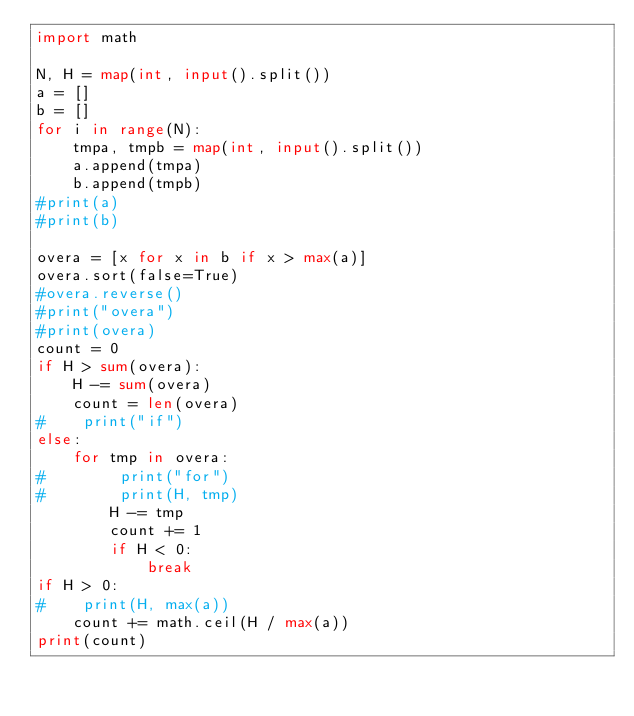<code> <loc_0><loc_0><loc_500><loc_500><_Python_>import math

N, H = map(int, input().split())
a = []
b = []
for i in range(N):
    tmpa, tmpb = map(int, input().split())
    a.append(tmpa)
    b.append(tmpb)
#print(a)
#print(b)

overa = [x for x in b if x > max(a)]
overa.sort(false=True)
#overa.reverse()
#print("overa")
#print(overa)
count = 0
if H > sum(overa):
    H -= sum(overa)
    count = len(overa)
#    print("if")
else:
    for tmp in overa:
#        print("for")
#        print(H, tmp)
        H -= tmp
        count += 1
        if H < 0:
            break
if H > 0:
#    print(H, max(a))
    count += math.ceil(H / max(a))
print(count)
</code> 